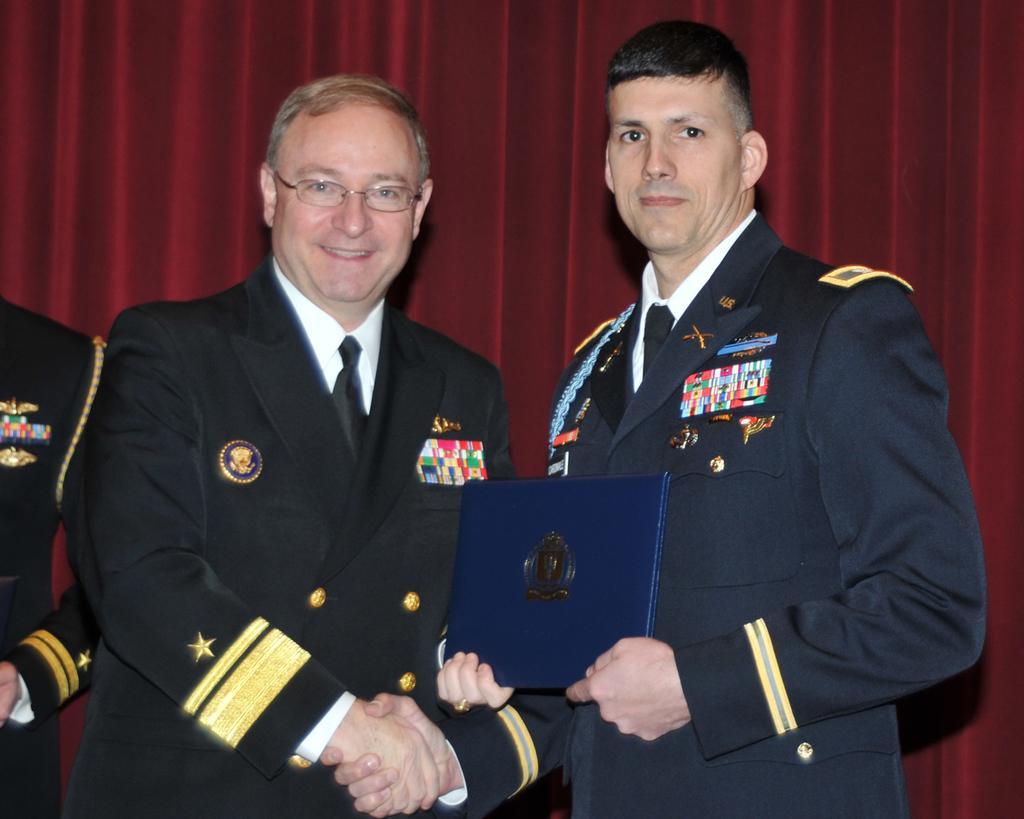How would you summarize this image in a sentence or two? In this image in the center there are two persons standing and smiling, and they are shaking hands with each other and they are holding book. And on the left side there is another person, and in the background there is a curtain. 